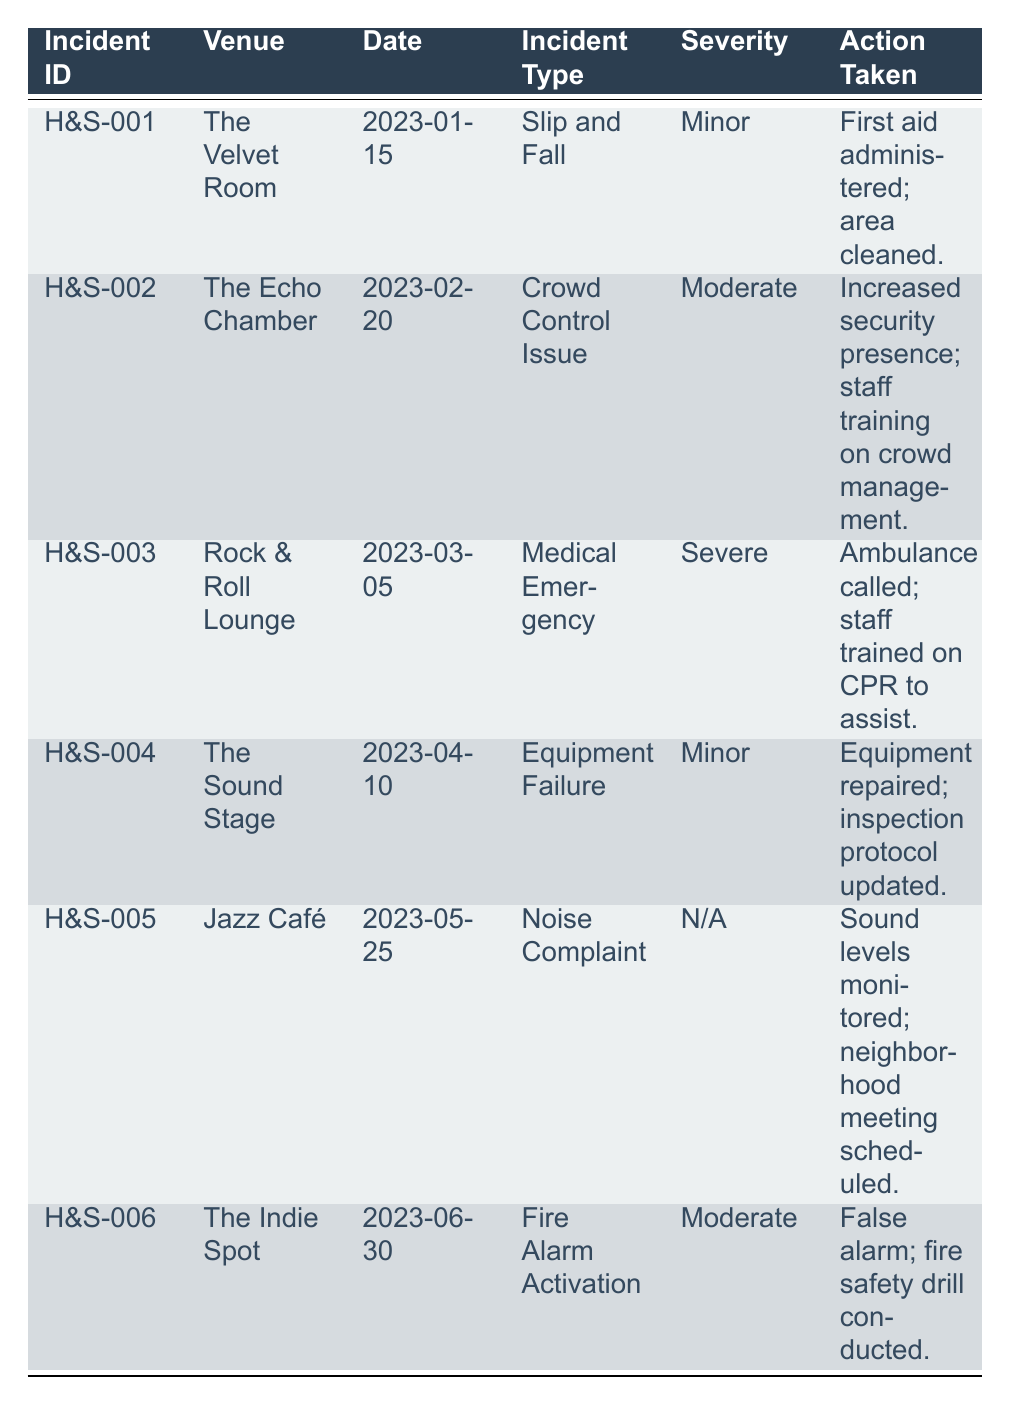What incident occurred at The Velvet Room? The table lists the specific incidents by venue. For The Velvet Room, the incident type is "Slip and Fall," as shown in the row corresponding to that venue.
Answer: Slip and Fall How many incidents reported were of "Moderate" severity? By examining the severity column, there are two incidents marked as "Moderate": one at The Echo Chamber and another at The Indie Spot. Therefore, the count is 2.
Answer: 2 What actions were taken for the Medical Emergency at the Rock & Roll Lounge? The table lists the action taken for the incident with ID H&S-003 at the Rock & Roll Lounge. It states that "Ambulance called; staff trained on CPR to assist."
Answer: Ambulance called; staff trained on CPR to assist Is there an incident involving equipment failure in the table? Looking through the incident types, there is one noted incident under "Equipment Failure" at The Sound Stage (H&S-004). Thus, this statement is true.
Answer: Yes What is the difference in the number of "Minor" and "Severe" incidents reported? The table indicates three incidents with a severity of "Minor" (H&S-001, H&S-004, and H&S-005) and one incident with a "Severe" severity (H&S-003). Therefore, the difference is 3 (Minor) - 1 (Severe) = 2.
Answer: 2 How many unique venues reported incidents in total? The unique venues listed in the table include The Velvet Room, The Echo Chamber, Rock & Roll Lounge, The Sound Stage, Jazz Café, and The Indie Spot, resulting in a total of 6 unique venues.
Answer: 6 What was the action taken for the noise complaint at Jazz Café? According to the table, the action recorded for the incident at Jazz Café (H&S-005) is "Sound levels monitored; neighborhood meeting scheduled."
Answer: Sound levels monitored; neighborhood meeting scheduled Were there any incidents on or after April 10, 2023? Looking at the date column, the incidents on or after April 10, 2023, include The Sound Stage on April 10, Jazz Café on May 25, and The Indie Spot on June 30. Therefore, the answer is yes.
Answer: Yes What is the average severity rating for the incidents? The severity ratings are (considering Minor=1, Moderate=2, Severe=3, N/A=0): H&S-001 (1) + H&S-002 (2) + H&S-003 (3) + H&S-004 (1) + H&S-005 (0) + H&S-006 (2) = 9/6 = 1.5, so the average severity rating is 1.5.
Answer: 1.5 